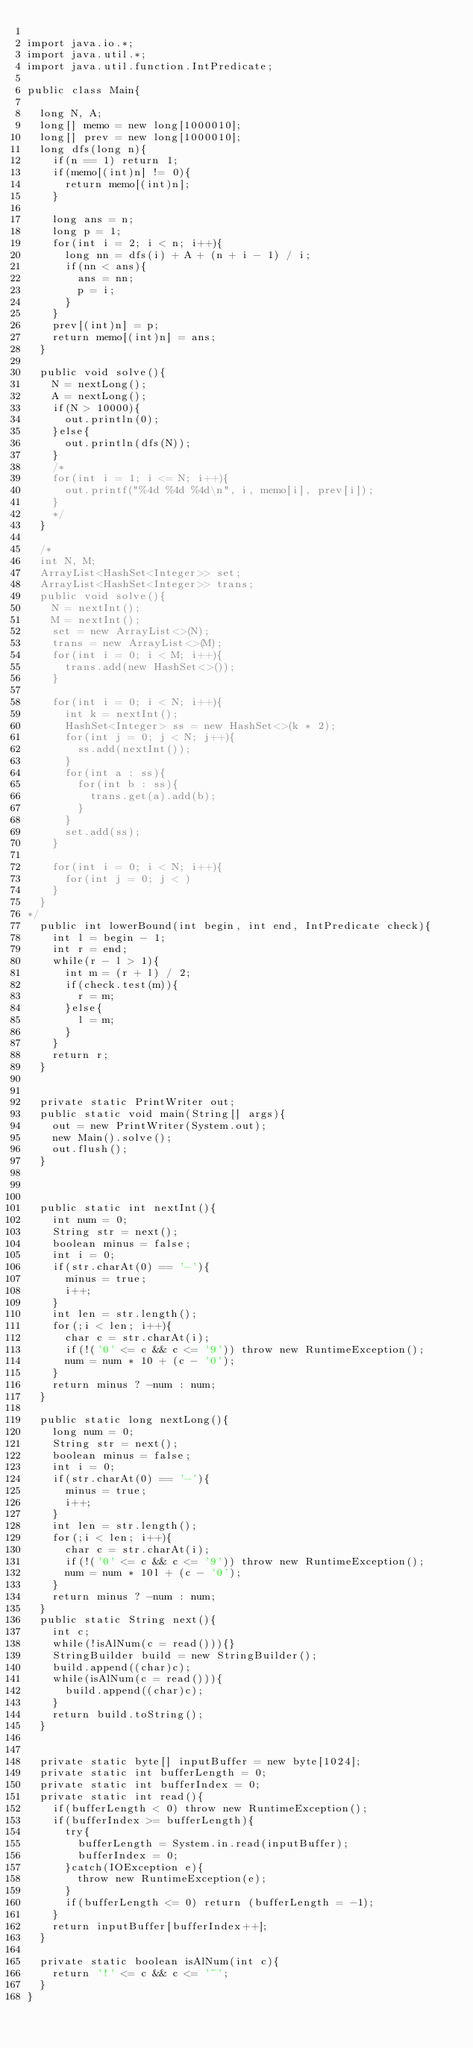<code> <loc_0><loc_0><loc_500><loc_500><_Java_>
import java.io.*;
import java.util.*;
import java.util.function.IntPredicate;
 
public class Main{
	
	long N, A;
	long[] memo = new long[1000010];
	long[] prev = new long[1000010];
	long dfs(long n){
		if(n == 1) return 1;
		if(memo[(int)n] != 0){
			return memo[(int)n];
		}
		
		long ans = n;
		long p = 1;
		for(int i = 2; i < n; i++){
			long nn = dfs(i) + A + (n + i - 1) / i;
			if(nn < ans){
				ans = nn;
				p = i;
			}
		}
		prev[(int)n] = p;
		return memo[(int)n] = ans;
	}
	
	public void solve(){
		N = nextLong();
		A = nextLong();
		if(N > 10000){
			out.println(0);
		}else{
			out.println(dfs(N));
		}
		/*
		for(int i = 1; i <= N; i++){
			out.printf("%4d %4d %4d\n", i, memo[i], prev[i]);
		}
		*/
	}
	
	/*
	int N, M;
	ArrayList<HashSet<Integer>> set;
	ArrayList<HashSet<Integer>> trans;
	public void solve(){
		N = nextInt();
		M = nextInt();
		set = new ArrayList<>(N);
		trans = new ArrayList<>(M);
		for(int i = 0; i < M; i++){
			trans.add(new HashSet<>());
		}
		
		for(int i = 0; i < N; i++){
			int k = nextInt();
			HashSet<Integer> ss = new HashSet<>(k * 2);
			for(int j = 0; j < N; j++){
				ss.add(nextInt());
			}
			for(int a : ss){
				for(int b : ss){
					trans.get(a).add(b);
				}
			}
			set.add(ss);
		}
		
		for(int i = 0; i < N; i++){
			for(int j = 0; j < )
		}
	}
*/
	public int lowerBound(int begin, int end, IntPredicate check){
		int l = begin - 1;
		int r = end;
		while(r - l > 1){
			int m = (r + l) / 2;
			if(check.test(m)){
				r = m;
			}else{
				l = m;
			}
		}
		return r;
	}
	
	
	private static PrintWriter out;
	public static void main(String[] args){
		out = new PrintWriter(System.out);
		new Main().solve();
		out.flush();
	}
	
	
	
	public static int nextInt(){
		int num = 0;
		String str = next();
		boolean minus = false;
		int i = 0;
		if(str.charAt(0) == '-'){
			minus = true;
			i++;
		}
		int len = str.length();
		for(;i < len; i++){
			char c = str.charAt(i);
			if(!('0' <= c && c <= '9')) throw new RuntimeException();
			num = num * 10 + (c - '0');
		}
		return minus ? -num : num;
	}
	
	public static long nextLong(){
		long num = 0;
		String str = next();
		boolean minus = false;
		int i = 0;
		if(str.charAt(0) == '-'){
			minus = true;
			i++;
		}
		int len = str.length();
		for(;i < len; i++){
			char c = str.charAt(i);
			if(!('0' <= c && c <= '9')) throw new RuntimeException();
			num = num * 10l + (c - '0');
		}
		return minus ? -num : num;
	}
	public static String next(){
		int c;
		while(!isAlNum(c = read())){}
		StringBuilder build = new StringBuilder();
		build.append((char)c);
		while(isAlNum(c = read())){
			build.append((char)c);
		}
		return build.toString();
	}
	
	
	private static byte[] inputBuffer = new byte[1024];
	private static int bufferLength = 0;
	private static int bufferIndex = 0;
	private static int read(){
		if(bufferLength < 0) throw new RuntimeException();
		if(bufferIndex >= bufferLength){
			try{
				bufferLength = System.in.read(inputBuffer);
				bufferIndex = 0;
			}catch(IOException e){
				throw new RuntimeException(e);
			}
			if(bufferLength <= 0) return (bufferLength = -1);
		}
		return inputBuffer[bufferIndex++];
	}
	
	private static boolean isAlNum(int c){
		return '!' <= c && c <= '~';
	}
}</code> 